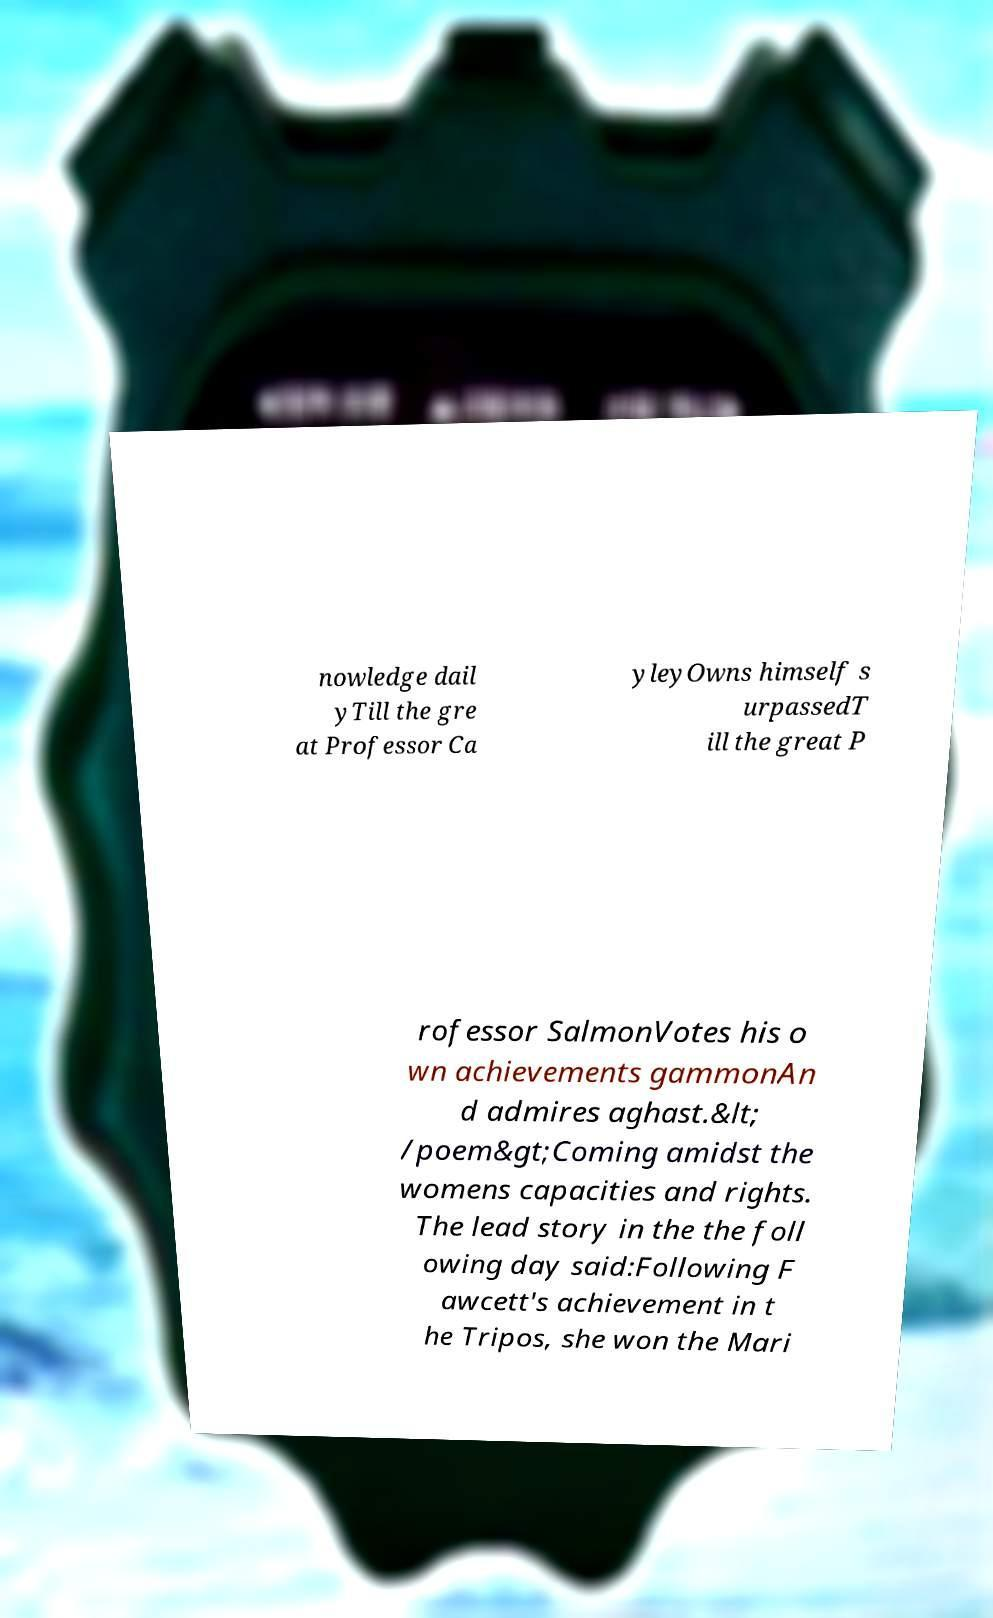Can you read and provide the text displayed in the image?This photo seems to have some interesting text. Can you extract and type it out for me? nowledge dail yTill the gre at Professor Ca yleyOwns himself s urpassedT ill the great P rofessor SalmonVotes his o wn achievements gammonAn d admires aghast.&lt; /poem&gt;Coming amidst the womens capacities and rights. The lead story in the the foll owing day said:Following F awcett's achievement in t he Tripos, she won the Mari 